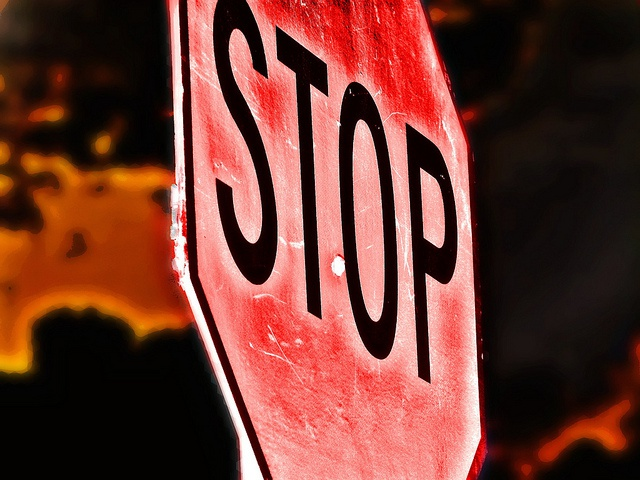Describe the objects in this image and their specific colors. I can see a stop sign in brown, lightpink, black, salmon, and red tones in this image. 